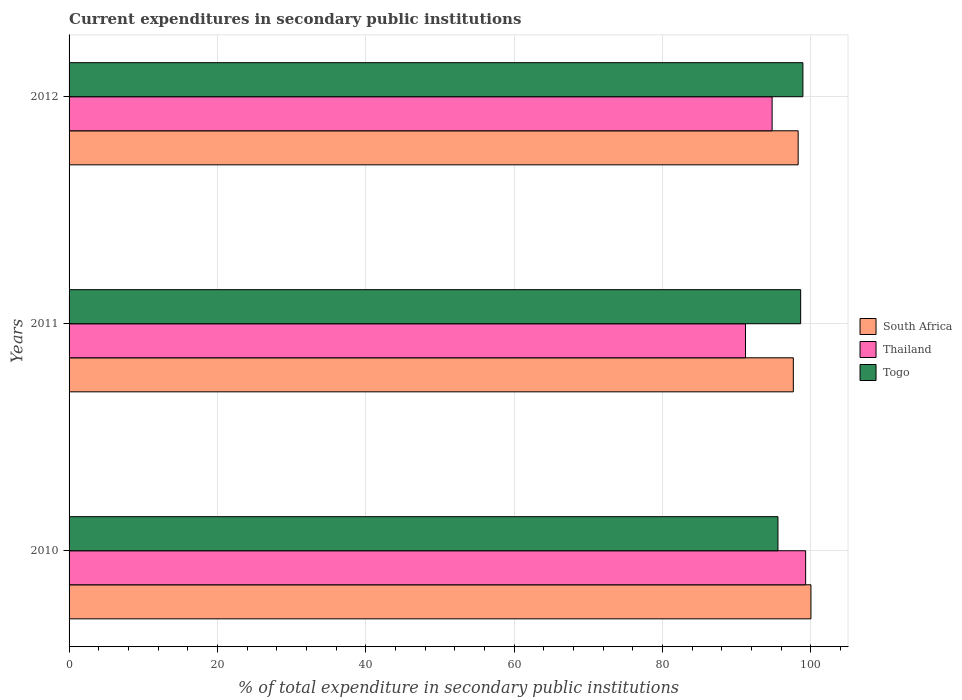How many different coloured bars are there?
Your answer should be very brief. 3. How many groups of bars are there?
Your response must be concise. 3. Are the number of bars on each tick of the Y-axis equal?
Provide a short and direct response. Yes. In how many cases, is the number of bars for a given year not equal to the number of legend labels?
Your response must be concise. 0. What is the current expenditures in secondary public institutions in Togo in 2010?
Provide a short and direct response. 95.55. Across all years, what is the maximum current expenditures in secondary public institutions in South Africa?
Offer a terse response. 100. Across all years, what is the minimum current expenditures in secondary public institutions in Togo?
Your answer should be very brief. 95.55. What is the total current expenditures in secondary public institutions in Thailand in the graph?
Keep it short and to the point. 285.24. What is the difference between the current expenditures in secondary public institutions in Thailand in 2011 and that in 2012?
Ensure brevity in your answer.  -3.59. What is the difference between the current expenditures in secondary public institutions in Thailand in 2011 and the current expenditures in secondary public institutions in South Africa in 2012?
Your answer should be very brief. -7.09. What is the average current expenditures in secondary public institutions in Thailand per year?
Keep it short and to the point. 95.08. In the year 2012, what is the difference between the current expenditures in secondary public institutions in Togo and current expenditures in secondary public institutions in South Africa?
Your answer should be very brief. 0.64. What is the ratio of the current expenditures in secondary public institutions in South Africa in 2010 to that in 2012?
Offer a terse response. 1.02. Is the difference between the current expenditures in secondary public institutions in Togo in 2010 and 2011 greater than the difference between the current expenditures in secondary public institutions in South Africa in 2010 and 2011?
Give a very brief answer. No. What is the difference between the highest and the second highest current expenditures in secondary public institutions in Togo?
Your answer should be very brief. 0.3. What is the difference between the highest and the lowest current expenditures in secondary public institutions in Togo?
Offer a terse response. 3.37. Is the sum of the current expenditures in secondary public institutions in Togo in 2011 and 2012 greater than the maximum current expenditures in secondary public institutions in Thailand across all years?
Give a very brief answer. Yes. What does the 3rd bar from the top in 2010 represents?
Your answer should be very brief. South Africa. What does the 2nd bar from the bottom in 2012 represents?
Provide a short and direct response. Thailand. Is it the case that in every year, the sum of the current expenditures in secondary public institutions in Togo and current expenditures in secondary public institutions in South Africa is greater than the current expenditures in secondary public institutions in Thailand?
Keep it short and to the point. Yes. Are all the bars in the graph horizontal?
Offer a terse response. Yes. How many years are there in the graph?
Offer a very short reply. 3. Are the values on the major ticks of X-axis written in scientific E-notation?
Offer a very short reply. No. Does the graph contain any zero values?
Ensure brevity in your answer.  No. Where does the legend appear in the graph?
Your response must be concise. Center right. How are the legend labels stacked?
Provide a short and direct response. Vertical. What is the title of the graph?
Keep it short and to the point. Current expenditures in secondary public institutions. Does "St. Lucia" appear as one of the legend labels in the graph?
Keep it short and to the point. No. What is the label or title of the X-axis?
Your answer should be compact. % of total expenditure in secondary public institutions. What is the label or title of the Y-axis?
Offer a terse response. Years. What is the % of total expenditure in secondary public institutions in Thailand in 2010?
Your answer should be very brief. 99.29. What is the % of total expenditure in secondary public institutions in Togo in 2010?
Keep it short and to the point. 95.55. What is the % of total expenditure in secondary public institutions of South Africa in 2011?
Ensure brevity in your answer.  97.63. What is the % of total expenditure in secondary public institutions of Thailand in 2011?
Ensure brevity in your answer.  91.18. What is the % of total expenditure in secondary public institutions of Togo in 2011?
Make the answer very short. 98.62. What is the % of total expenditure in secondary public institutions in South Africa in 2012?
Provide a succinct answer. 98.28. What is the % of total expenditure in secondary public institutions in Thailand in 2012?
Provide a short and direct response. 94.77. What is the % of total expenditure in secondary public institutions in Togo in 2012?
Make the answer very short. 98.92. Across all years, what is the maximum % of total expenditure in secondary public institutions of South Africa?
Ensure brevity in your answer.  100. Across all years, what is the maximum % of total expenditure in secondary public institutions of Thailand?
Ensure brevity in your answer.  99.29. Across all years, what is the maximum % of total expenditure in secondary public institutions of Togo?
Give a very brief answer. 98.92. Across all years, what is the minimum % of total expenditure in secondary public institutions in South Africa?
Your answer should be compact. 97.63. Across all years, what is the minimum % of total expenditure in secondary public institutions of Thailand?
Your response must be concise. 91.18. Across all years, what is the minimum % of total expenditure in secondary public institutions of Togo?
Keep it short and to the point. 95.55. What is the total % of total expenditure in secondary public institutions of South Africa in the graph?
Make the answer very short. 295.9. What is the total % of total expenditure in secondary public institutions of Thailand in the graph?
Provide a short and direct response. 285.24. What is the total % of total expenditure in secondary public institutions in Togo in the graph?
Provide a succinct answer. 293.09. What is the difference between the % of total expenditure in secondary public institutions of South Africa in 2010 and that in 2011?
Ensure brevity in your answer.  2.37. What is the difference between the % of total expenditure in secondary public institutions of Thailand in 2010 and that in 2011?
Give a very brief answer. 8.1. What is the difference between the % of total expenditure in secondary public institutions of Togo in 2010 and that in 2011?
Your answer should be very brief. -3.06. What is the difference between the % of total expenditure in secondary public institutions of South Africa in 2010 and that in 2012?
Offer a terse response. 1.72. What is the difference between the % of total expenditure in secondary public institutions of Thailand in 2010 and that in 2012?
Offer a terse response. 4.52. What is the difference between the % of total expenditure in secondary public institutions in Togo in 2010 and that in 2012?
Keep it short and to the point. -3.37. What is the difference between the % of total expenditure in secondary public institutions of South Africa in 2011 and that in 2012?
Keep it short and to the point. -0.65. What is the difference between the % of total expenditure in secondary public institutions in Thailand in 2011 and that in 2012?
Ensure brevity in your answer.  -3.59. What is the difference between the % of total expenditure in secondary public institutions in Togo in 2011 and that in 2012?
Offer a very short reply. -0.3. What is the difference between the % of total expenditure in secondary public institutions in South Africa in 2010 and the % of total expenditure in secondary public institutions in Thailand in 2011?
Keep it short and to the point. 8.82. What is the difference between the % of total expenditure in secondary public institutions in South Africa in 2010 and the % of total expenditure in secondary public institutions in Togo in 2011?
Offer a very short reply. 1.38. What is the difference between the % of total expenditure in secondary public institutions in Thailand in 2010 and the % of total expenditure in secondary public institutions in Togo in 2011?
Offer a terse response. 0.67. What is the difference between the % of total expenditure in secondary public institutions in South Africa in 2010 and the % of total expenditure in secondary public institutions in Thailand in 2012?
Give a very brief answer. 5.23. What is the difference between the % of total expenditure in secondary public institutions in South Africa in 2010 and the % of total expenditure in secondary public institutions in Togo in 2012?
Provide a short and direct response. 1.08. What is the difference between the % of total expenditure in secondary public institutions in Thailand in 2010 and the % of total expenditure in secondary public institutions in Togo in 2012?
Ensure brevity in your answer.  0.37. What is the difference between the % of total expenditure in secondary public institutions in South Africa in 2011 and the % of total expenditure in secondary public institutions in Thailand in 2012?
Your answer should be very brief. 2.86. What is the difference between the % of total expenditure in secondary public institutions of South Africa in 2011 and the % of total expenditure in secondary public institutions of Togo in 2012?
Give a very brief answer. -1.29. What is the difference between the % of total expenditure in secondary public institutions in Thailand in 2011 and the % of total expenditure in secondary public institutions in Togo in 2012?
Your answer should be very brief. -7.74. What is the average % of total expenditure in secondary public institutions in South Africa per year?
Provide a succinct answer. 98.63. What is the average % of total expenditure in secondary public institutions of Thailand per year?
Offer a very short reply. 95.08. What is the average % of total expenditure in secondary public institutions of Togo per year?
Your response must be concise. 97.7. In the year 2010, what is the difference between the % of total expenditure in secondary public institutions in South Africa and % of total expenditure in secondary public institutions in Thailand?
Provide a short and direct response. 0.71. In the year 2010, what is the difference between the % of total expenditure in secondary public institutions in South Africa and % of total expenditure in secondary public institutions in Togo?
Provide a short and direct response. 4.45. In the year 2010, what is the difference between the % of total expenditure in secondary public institutions of Thailand and % of total expenditure in secondary public institutions of Togo?
Make the answer very short. 3.73. In the year 2011, what is the difference between the % of total expenditure in secondary public institutions in South Africa and % of total expenditure in secondary public institutions in Thailand?
Make the answer very short. 6.44. In the year 2011, what is the difference between the % of total expenditure in secondary public institutions of South Africa and % of total expenditure in secondary public institutions of Togo?
Make the answer very short. -0.99. In the year 2011, what is the difference between the % of total expenditure in secondary public institutions in Thailand and % of total expenditure in secondary public institutions in Togo?
Offer a terse response. -7.43. In the year 2012, what is the difference between the % of total expenditure in secondary public institutions of South Africa and % of total expenditure in secondary public institutions of Thailand?
Your answer should be very brief. 3.51. In the year 2012, what is the difference between the % of total expenditure in secondary public institutions in South Africa and % of total expenditure in secondary public institutions in Togo?
Keep it short and to the point. -0.64. In the year 2012, what is the difference between the % of total expenditure in secondary public institutions of Thailand and % of total expenditure in secondary public institutions of Togo?
Make the answer very short. -4.15. What is the ratio of the % of total expenditure in secondary public institutions in South Africa in 2010 to that in 2011?
Offer a terse response. 1.02. What is the ratio of the % of total expenditure in secondary public institutions in Thailand in 2010 to that in 2011?
Your response must be concise. 1.09. What is the ratio of the % of total expenditure in secondary public institutions of Togo in 2010 to that in 2011?
Make the answer very short. 0.97. What is the ratio of the % of total expenditure in secondary public institutions of South Africa in 2010 to that in 2012?
Ensure brevity in your answer.  1.02. What is the ratio of the % of total expenditure in secondary public institutions in Thailand in 2010 to that in 2012?
Ensure brevity in your answer.  1.05. What is the ratio of the % of total expenditure in secondary public institutions in South Africa in 2011 to that in 2012?
Provide a succinct answer. 0.99. What is the ratio of the % of total expenditure in secondary public institutions in Thailand in 2011 to that in 2012?
Offer a terse response. 0.96. What is the ratio of the % of total expenditure in secondary public institutions in Togo in 2011 to that in 2012?
Your response must be concise. 1. What is the difference between the highest and the second highest % of total expenditure in secondary public institutions of South Africa?
Ensure brevity in your answer.  1.72. What is the difference between the highest and the second highest % of total expenditure in secondary public institutions in Thailand?
Offer a terse response. 4.52. What is the difference between the highest and the second highest % of total expenditure in secondary public institutions in Togo?
Provide a succinct answer. 0.3. What is the difference between the highest and the lowest % of total expenditure in secondary public institutions in South Africa?
Offer a terse response. 2.37. What is the difference between the highest and the lowest % of total expenditure in secondary public institutions of Thailand?
Give a very brief answer. 8.1. What is the difference between the highest and the lowest % of total expenditure in secondary public institutions in Togo?
Offer a very short reply. 3.37. 